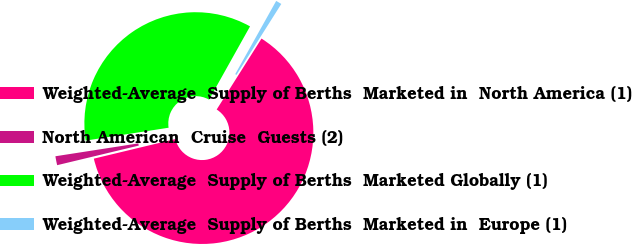Convert chart. <chart><loc_0><loc_0><loc_500><loc_500><pie_chart><fcel>Weighted-Average  Supply of Berths  Marketed in  North America (1)<fcel>North American  Cruise  Guests (2)<fcel>Weighted-Average  Supply of Berths  Marketed Globally (1)<fcel>Weighted-Average  Supply of Berths  Marketed in  Europe (1)<nl><fcel>62.28%<fcel>1.3%<fcel>35.57%<fcel>0.85%<nl></chart> 